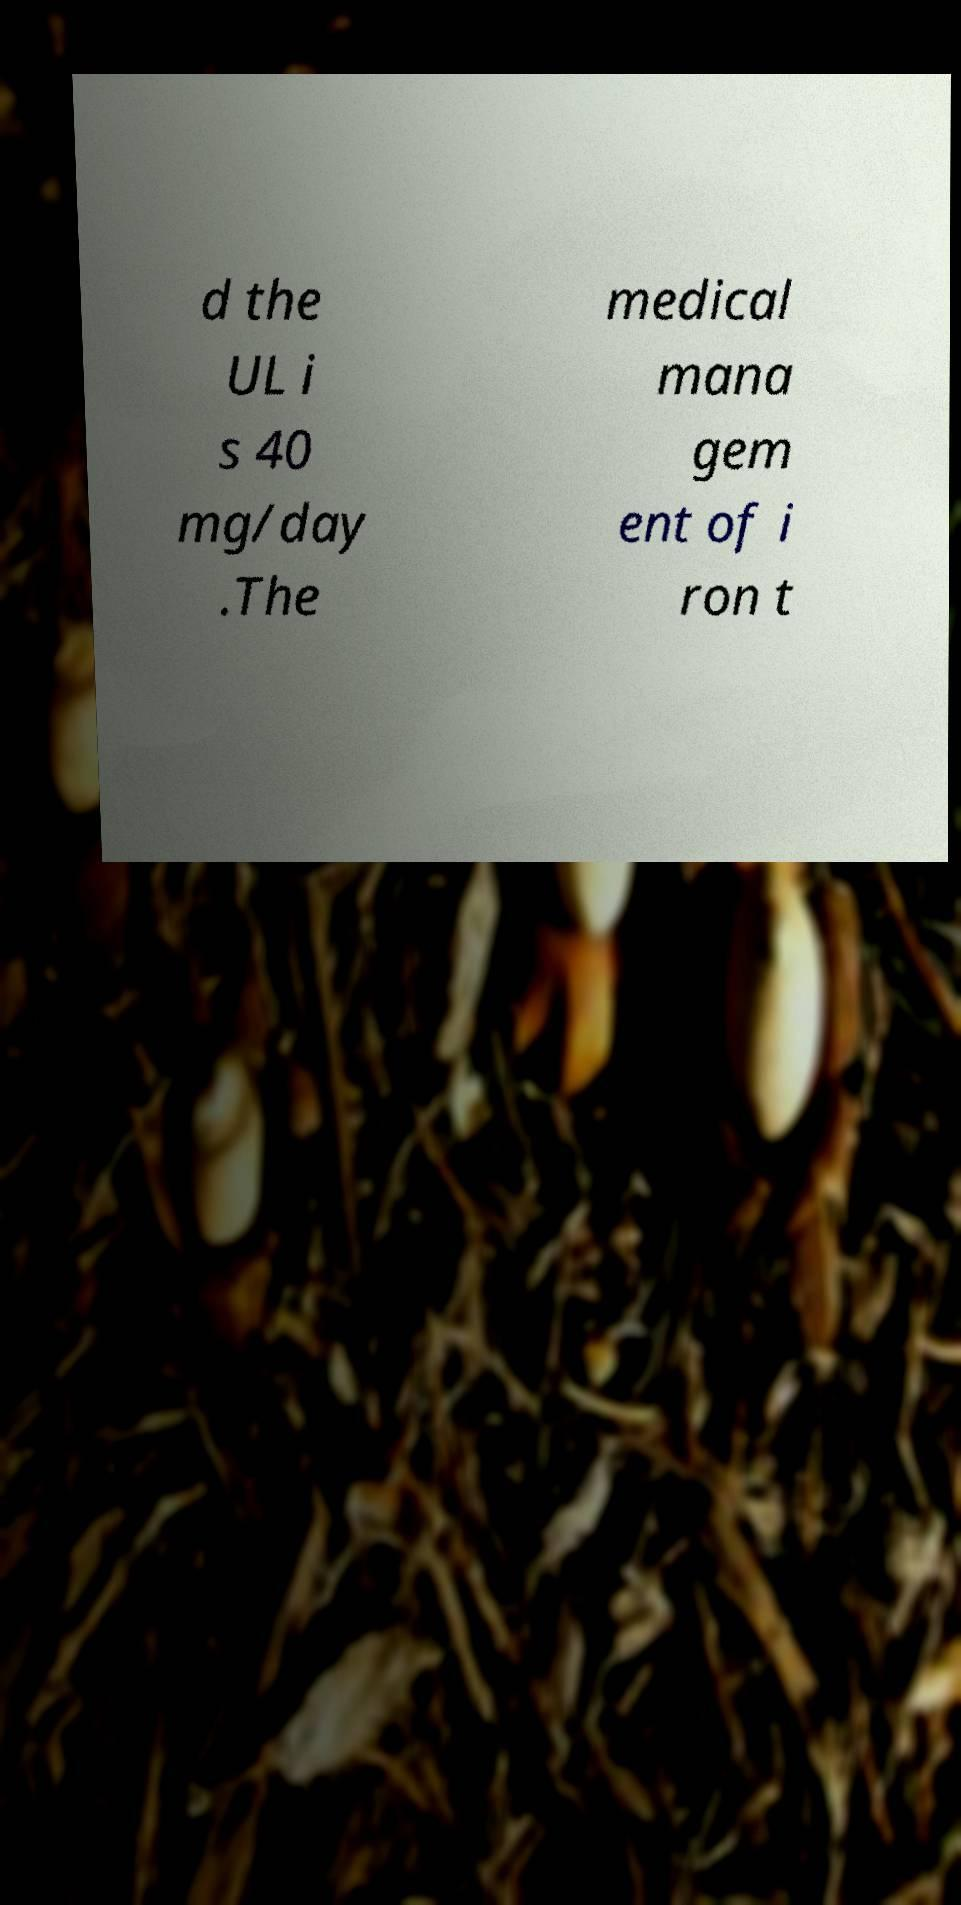For documentation purposes, I need the text within this image transcribed. Could you provide that? d the UL i s 40 mg/day .The medical mana gem ent of i ron t 